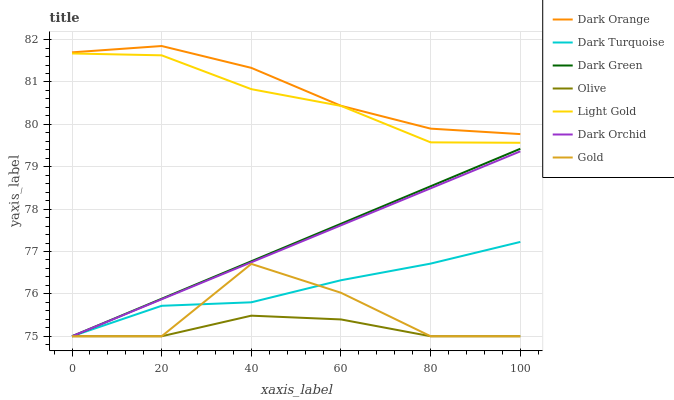Does Olive have the minimum area under the curve?
Answer yes or no. Yes. Does Dark Orange have the maximum area under the curve?
Answer yes or no. Yes. Does Gold have the minimum area under the curve?
Answer yes or no. No. Does Gold have the maximum area under the curve?
Answer yes or no. No. Is Dark Green the smoothest?
Answer yes or no. Yes. Is Gold the roughest?
Answer yes or no. Yes. Is Dark Turquoise the smoothest?
Answer yes or no. No. Is Dark Turquoise the roughest?
Answer yes or no. No. Does Light Gold have the lowest value?
Answer yes or no. No. Does Gold have the highest value?
Answer yes or no. No. Is Dark Orchid less than Light Gold?
Answer yes or no. Yes. Is Light Gold greater than Olive?
Answer yes or no. Yes. Does Dark Orchid intersect Light Gold?
Answer yes or no. No. 